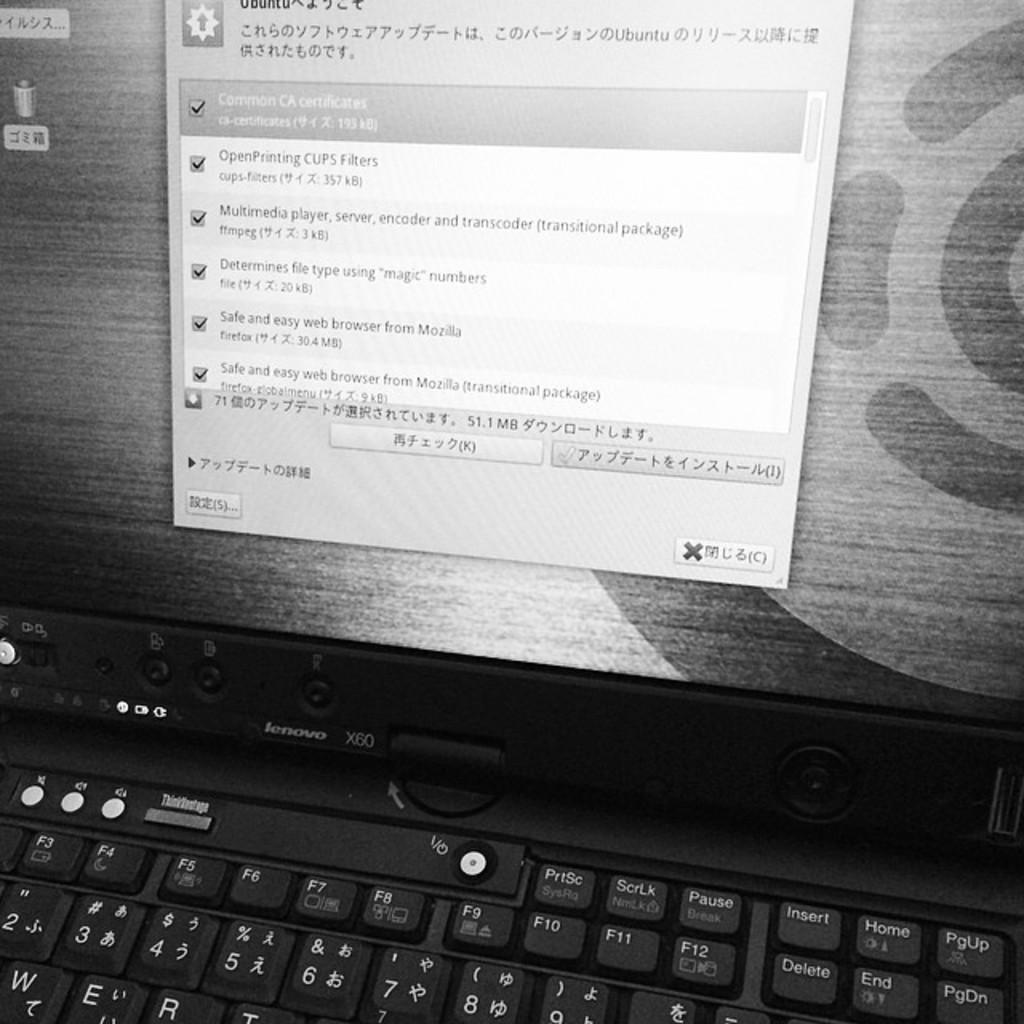What letter comes before the numbers on the computer?
Keep it short and to the point. X. Determines the file type with what kind of numbers?
Your answer should be compact. Magic. 